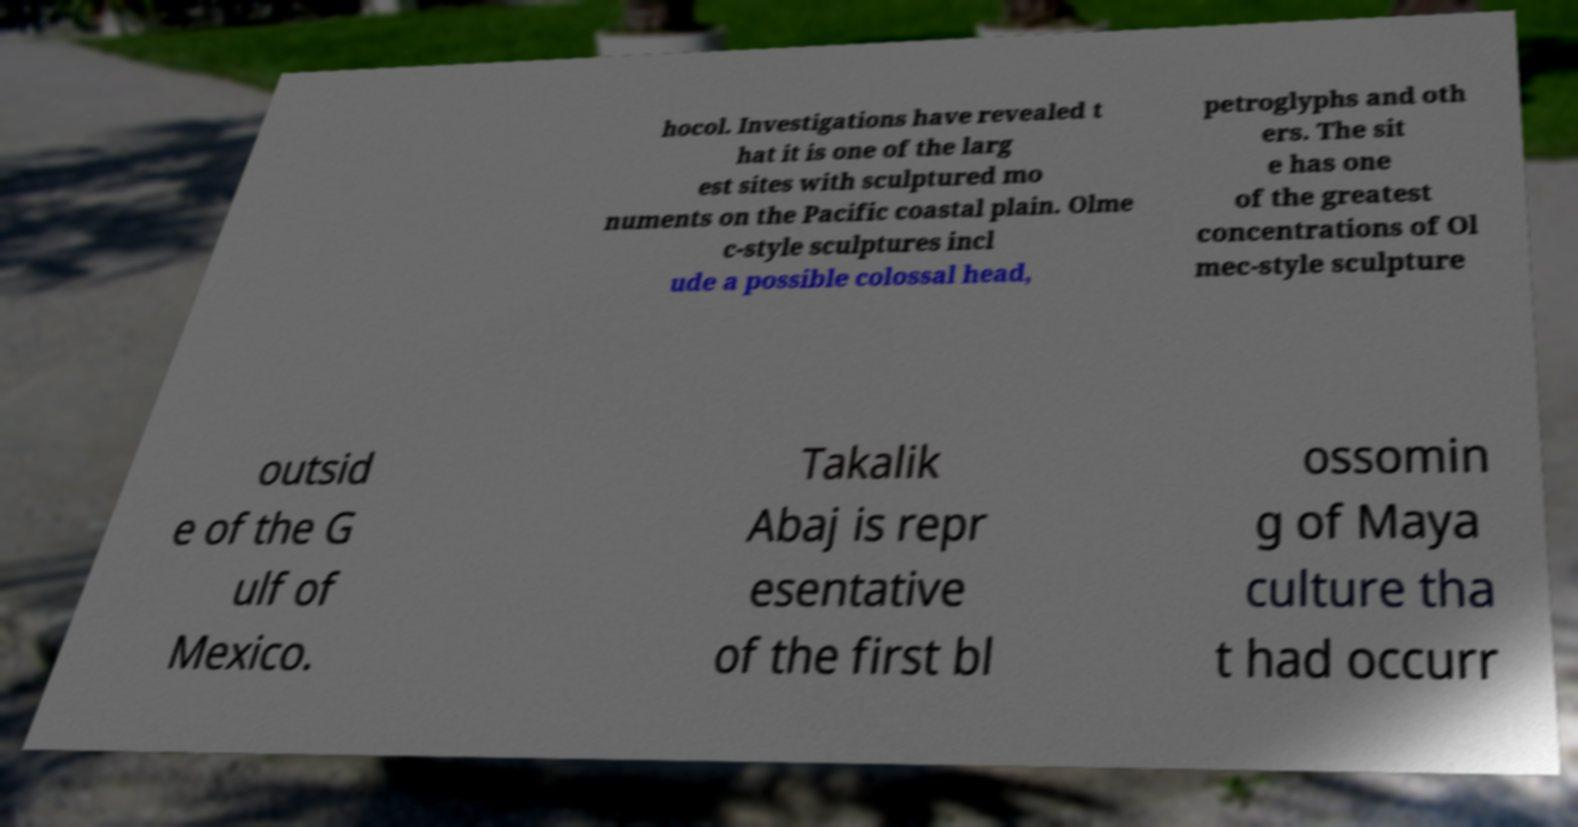Please read and relay the text visible in this image. What does it say? hocol. Investigations have revealed t hat it is one of the larg est sites with sculptured mo numents on the Pacific coastal plain. Olme c-style sculptures incl ude a possible colossal head, petroglyphs and oth ers. The sit e has one of the greatest concentrations of Ol mec-style sculpture outsid e of the G ulf of Mexico. Takalik Abaj is repr esentative of the first bl ossomin g of Maya culture tha t had occurr 